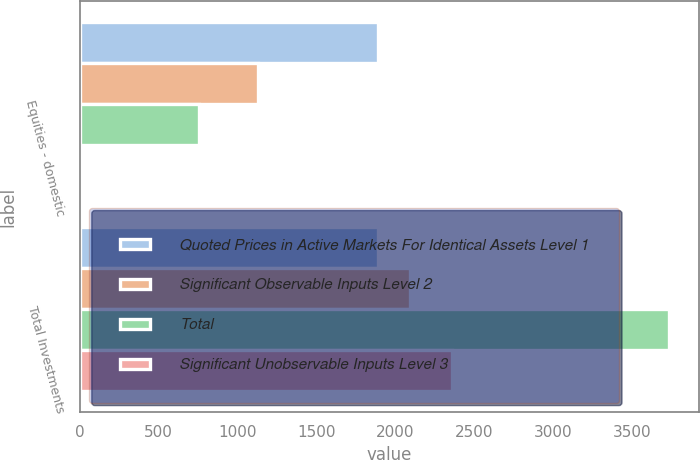Convert chart. <chart><loc_0><loc_0><loc_500><loc_500><stacked_bar_chart><ecel><fcel>Equities - domestic<fcel>Total Investments<nl><fcel>Quoted Prices in Active Markets For Identical Assets Level 1<fcel>1889<fcel>1889<nl><fcel>Significant Observable Inputs Level 2<fcel>1130<fcel>2091<nl><fcel>Total<fcel>758<fcel>3737<nl><fcel>Significant Unobservable Inputs Level 3<fcel>1<fcel>2357<nl></chart> 